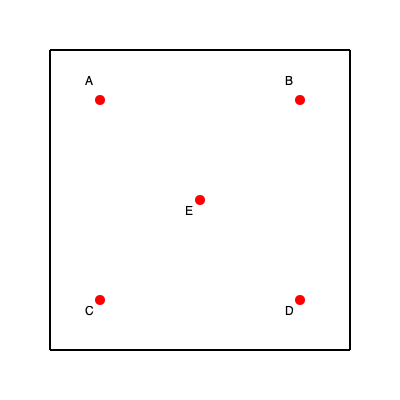As a podcast host discussing local elections, you're planning to visit all polling stations in Hartlepool. The simplified map shows 5 polling stations (A, B, C, D, and E) in a grid layout. Each grid square represents 1 km. What is the shortest route in kilometers to visit all polling stations, starting and ending at station A? To find the shortest route, we need to consider all possible paths and minimize the total distance traveled. Let's break it down step-by-step:

1. Distances between stations:
   - A to B: 4 km
   - A to C: 4 km
   - A to E: $2\sqrt{2}$ km (diagonal)
   - B to D: 4 km
   - B to E: $2\sqrt{2}$ km
   - C to D: 4 km
   - C to E: $2\sqrt{2}$ km
   - D to E: $2\sqrt{2}$ km

2. Possible routes (starting and ending at A):
   a) A -> B -> D -> C -> E -> A
   b) A -> C -> D -> B -> E -> A
   c) A -> E -> B -> D -> C -> A
   d) A -> E -> C -> D -> B -> A

3. Calculating distances for each route:
   a) $4 + 4 + 4 + 2\sqrt{2} + 2\sqrt{2} = 12 + 2\sqrt{8}$ km
   b) $4 + 4 + 4 + 2\sqrt{2} + 2\sqrt{2} = 12 + 2\sqrt{8}$ km
   c) $2\sqrt{2} + 4 + 4 + 2\sqrt{2} + 2\sqrt{2} = 8 + 3\sqrt{8}$ km
   d) $2\sqrt{2} + 4 + 4 + 2\sqrt{2} + 2\sqrt{2} = 8 + 3\sqrt{8}$ km

4. Comparing the routes:
   Routes (a) and (b) have the same distance: $12 + 2\sqrt{8}$ km
   Routes (c) and (d) have the same distance: $8 + 3\sqrt{8}$ km

5. Simplifying $\sqrt{8}$ to $2\sqrt{2}$:
   Routes (a) and (b): $12 + 2(2\sqrt{2}) = 12 + 4\sqrt{2}$ km
   Routes (c) and (d): $8 + 3(2\sqrt{2}) = 8 + 6\sqrt{2}$ km

6. Comparing the simplified distances:
   $12 + 4\sqrt{2} > 8 + 6\sqrt{2}$

Therefore, the shortest route is either (c) or (d), with a distance of $8 + 6\sqrt{2}$ km.
Answer: $8 + 6\sqrt{2}$ km 